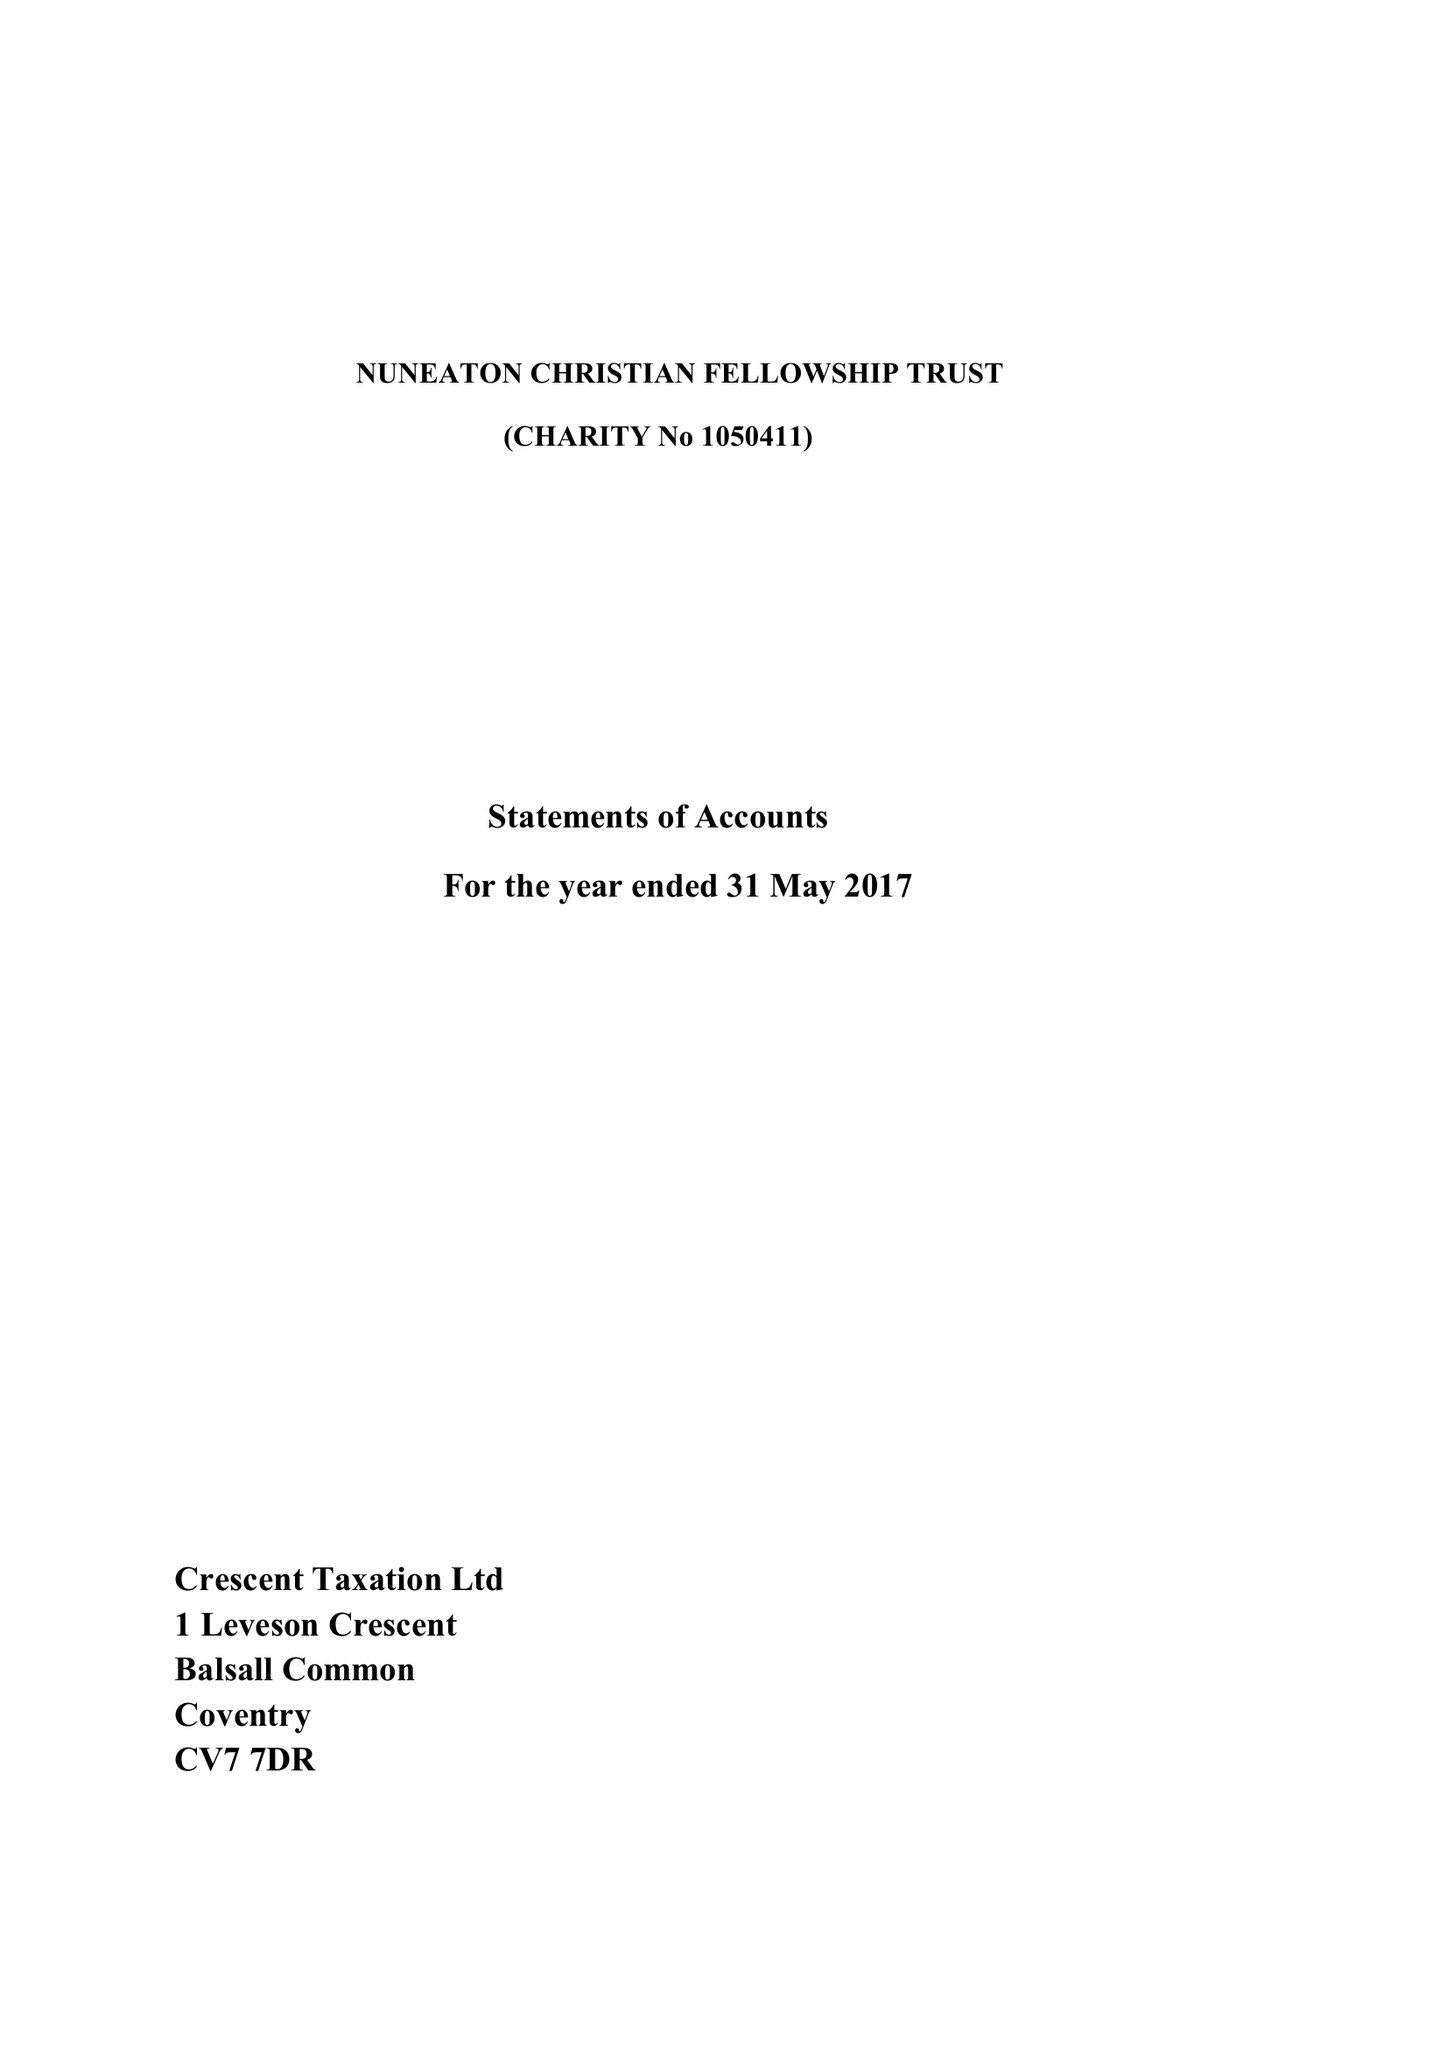What is the value for the income_annually_in_british_pounds?
Answer the question using a single word or phrase. 33395.00 